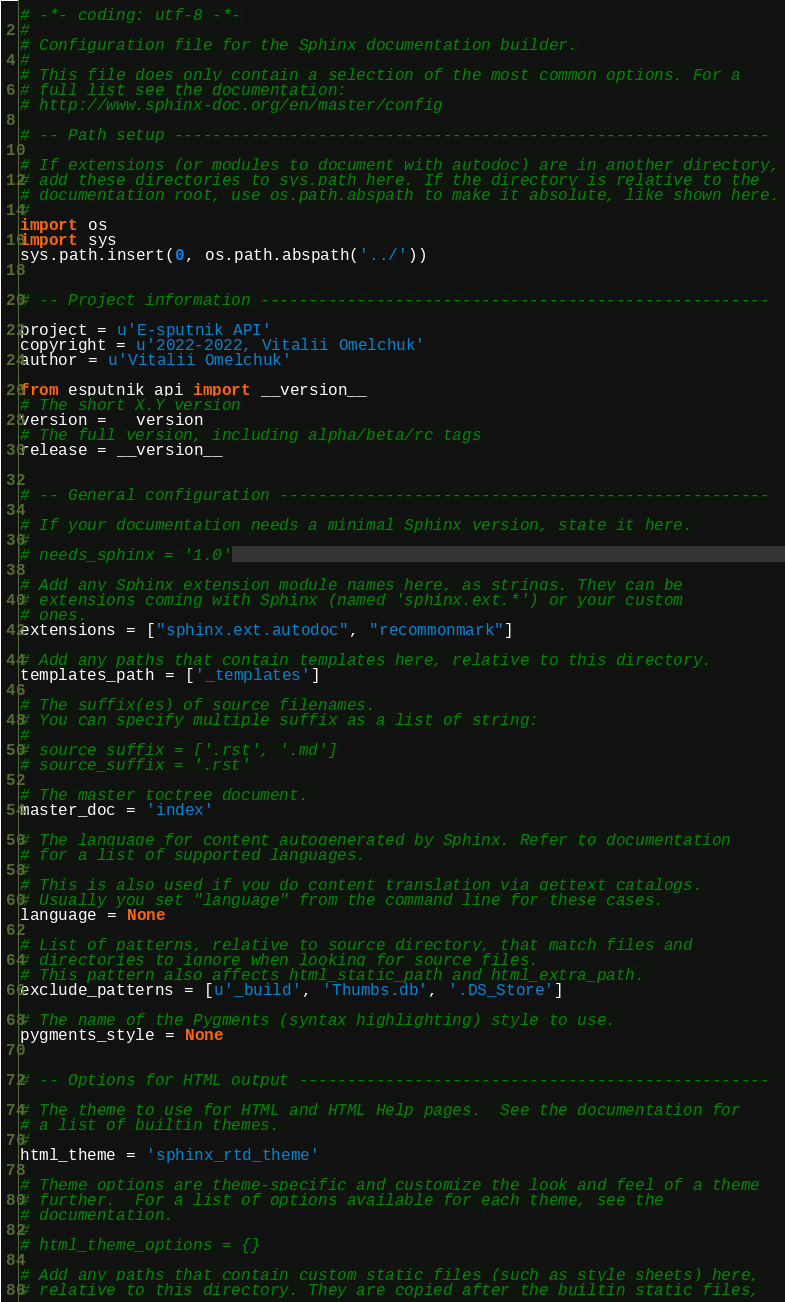<code> <loc_0><loc_0><loc_500><loc_500><_Python_># -*- coding: utf-8 -*-
#
# Configuration file for the Sphinx documentation builder.
#
# This file does only contain a selection of the most common options. For a
# full list see the documentation:
# http://www.sphinx-doc.org/en/master/config

# -- Path setup --------------------------------------------------------------

# If extensions (or modules to document with autodoc) are in another directory,
# add these directories to sys.path here. If the directory is relative to the
# documentation root, use os.path.abspath to make it absolute, like shown here.
#
import os
import sys
sys.path.insert(0, os.path.abspath('../'))


# -- Project information -----------------------------------------------------

project = u'E-sputnik API'
copyright = u'2022-2022, Vitalii Omelchuk'
author = u'Vitalii Omelchuk'

from esputnik_api import __version__
# The short X.Y version
version = __version__
# The full version, including alpha/beta/rc tags
release = __version__


# -- General configuration ---------------------------------------------------

# If your documentation needs a minimal Sphinx version, state it here.
#
# needs_sphinx = '1.0'

# Add any Sphinx extension module names here, as strings. They can be
# extensions coming with Sphinx (named 'sphinx.ext.*') or your custom
# ones.
extensions = ["sphinx.ext.autodoc", "recommonmark"]

# Add any paths that contain templates here, relative to this directory.
templates_path = ['_templates']

# The suffix(es) of source filenames.
# You can specify multiple suffix as a list of string:
#
# source_suffix = ['.rst', '.md']
# source_suffix = '.rst'

# The master toctree document.
master_doc = 'index'

# The language for content autogenerated by Sphinx. Refer to documentation
# for a list of supported languages.
#
# This is also used if you do content translation via gettext catalogs.
# Usually you set "language" from the command line for these cases.
language = None

# List of patterns, relative to source directory, that match files and
# directories to ignore when looking for source files.
# This pattern also affects html_static_path and html_extra_path.
exclude_patterns = [u'_build', 'Thumbs.db', '.DS_Store']

# The name of the Pygments (syntax highlighting) style to use.
pygments_style = None


# -- Options for HTML output -------------------------------------------------

# The theme to use for HTML and HTML Help pages.  See the documentation for
# a list of builtin themes.
#
html_theme = 'sphinx_rtd_theme'

# Theme options are theme-specific and customize the look and feel of a theme
# further.  For a list of options available for each theme, see the
# documentation.
#
# html_theme_options = {}

# Add any paths that contain custom static files (such as style sheets) here,
# relative to this directory. They are copied after the builtin static files,</code> 